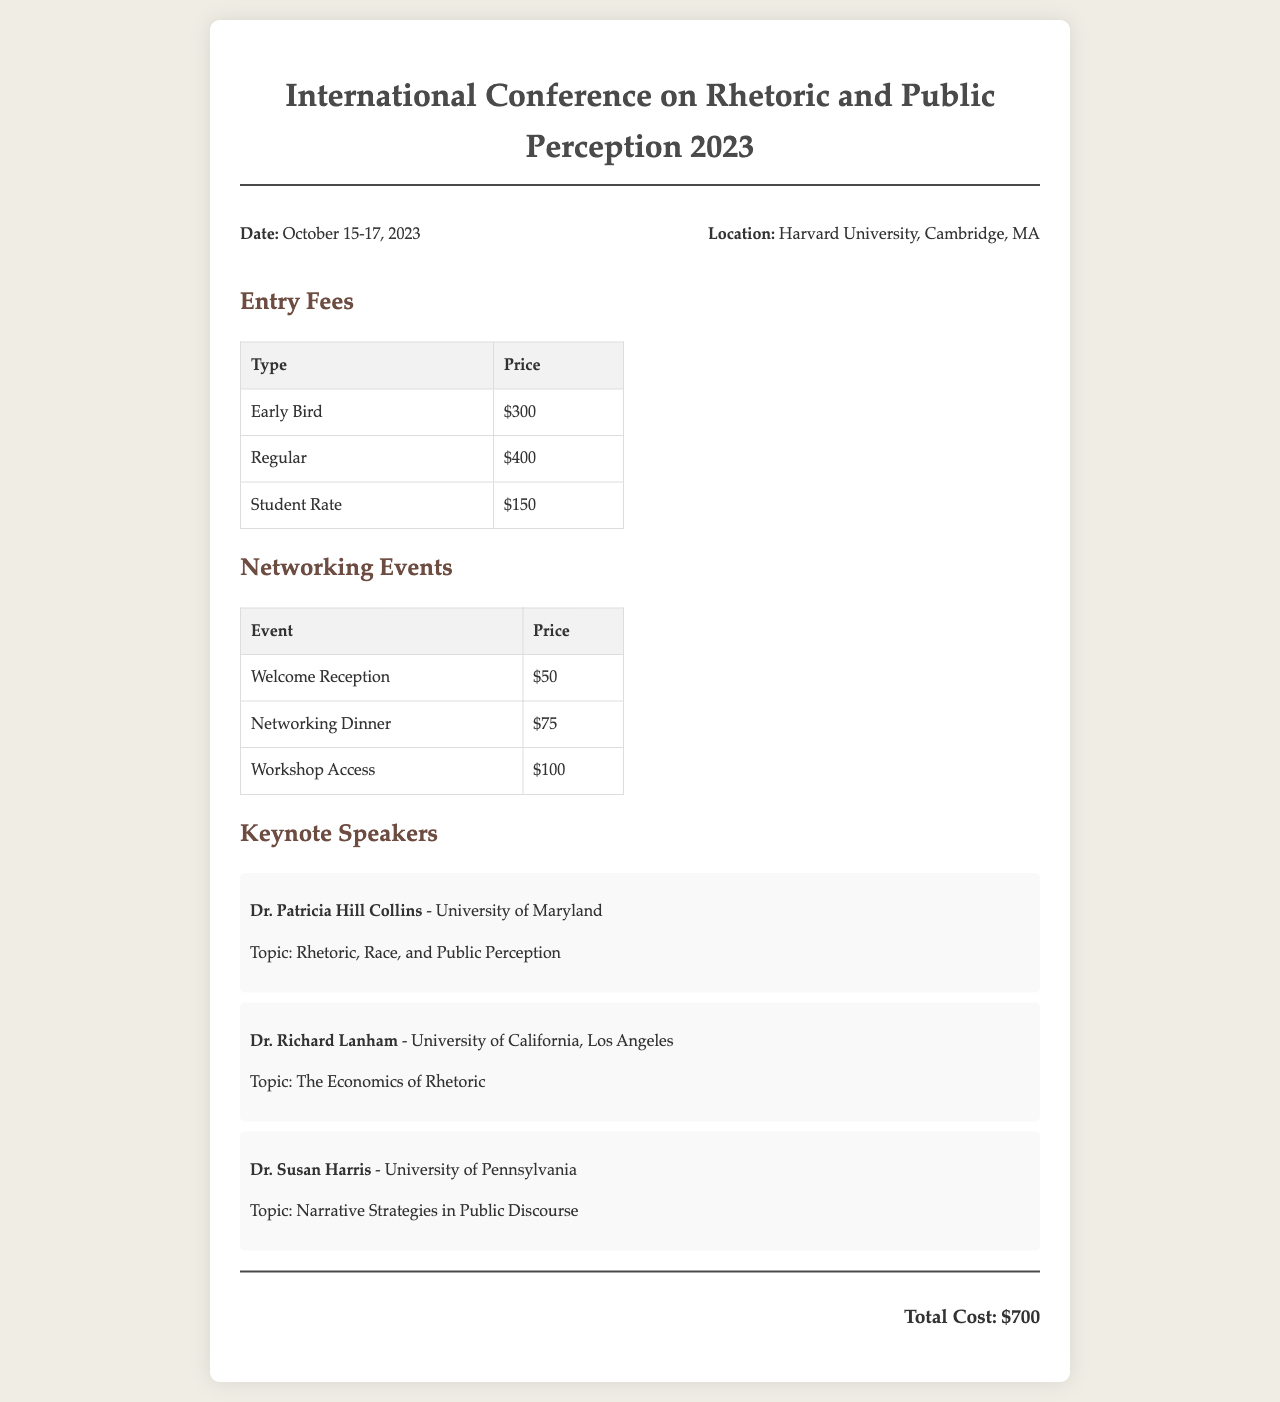What is the total cost of attending the conference? The total cost is explicitly stated at the bottom of the document, summarizing all fees.
Answer: $700 What is the date of the conference? The date is provided at the beginning of the document, indicating when the event occurs.
Answer: October 15-17, 2023 Who is the keynote speaker from the University of Maryland? The document lists keynote speakers with their affiliations and topics, from which this information can be derived.
Answer: Dr. Patricia Hill Collins What is the price for the Networking Dinner? This information is found in the table listing networking event costs, highlighting specific fees for each event.
Answer: $75 What is the student rate for entry fees? The document includes entry fees structured by category, which falls under this specific query.
Answer: $150 How many keynote speakers are listed in the document? The total number of speakers is counted from the section detailing keynote presentations and names.
Answer: 3 What is the price for the Workshop Access? The fee for specific networking events is mentioned in a distinct table, providing clarity on costs for attendees.
Answer: $100 Which university is Dr. Richard Lanham affiliated with? The speaker's affiliation is explicitly mentioned alongside their name and topic in the document.
Answer: University of California, Los Angeles What is the topic of Dr. Susan Harris's keynote speech? Each speaker's topic is provided in their respective sections, directly answering this question.
Answer: Narrative Strategies in Public Discourse 